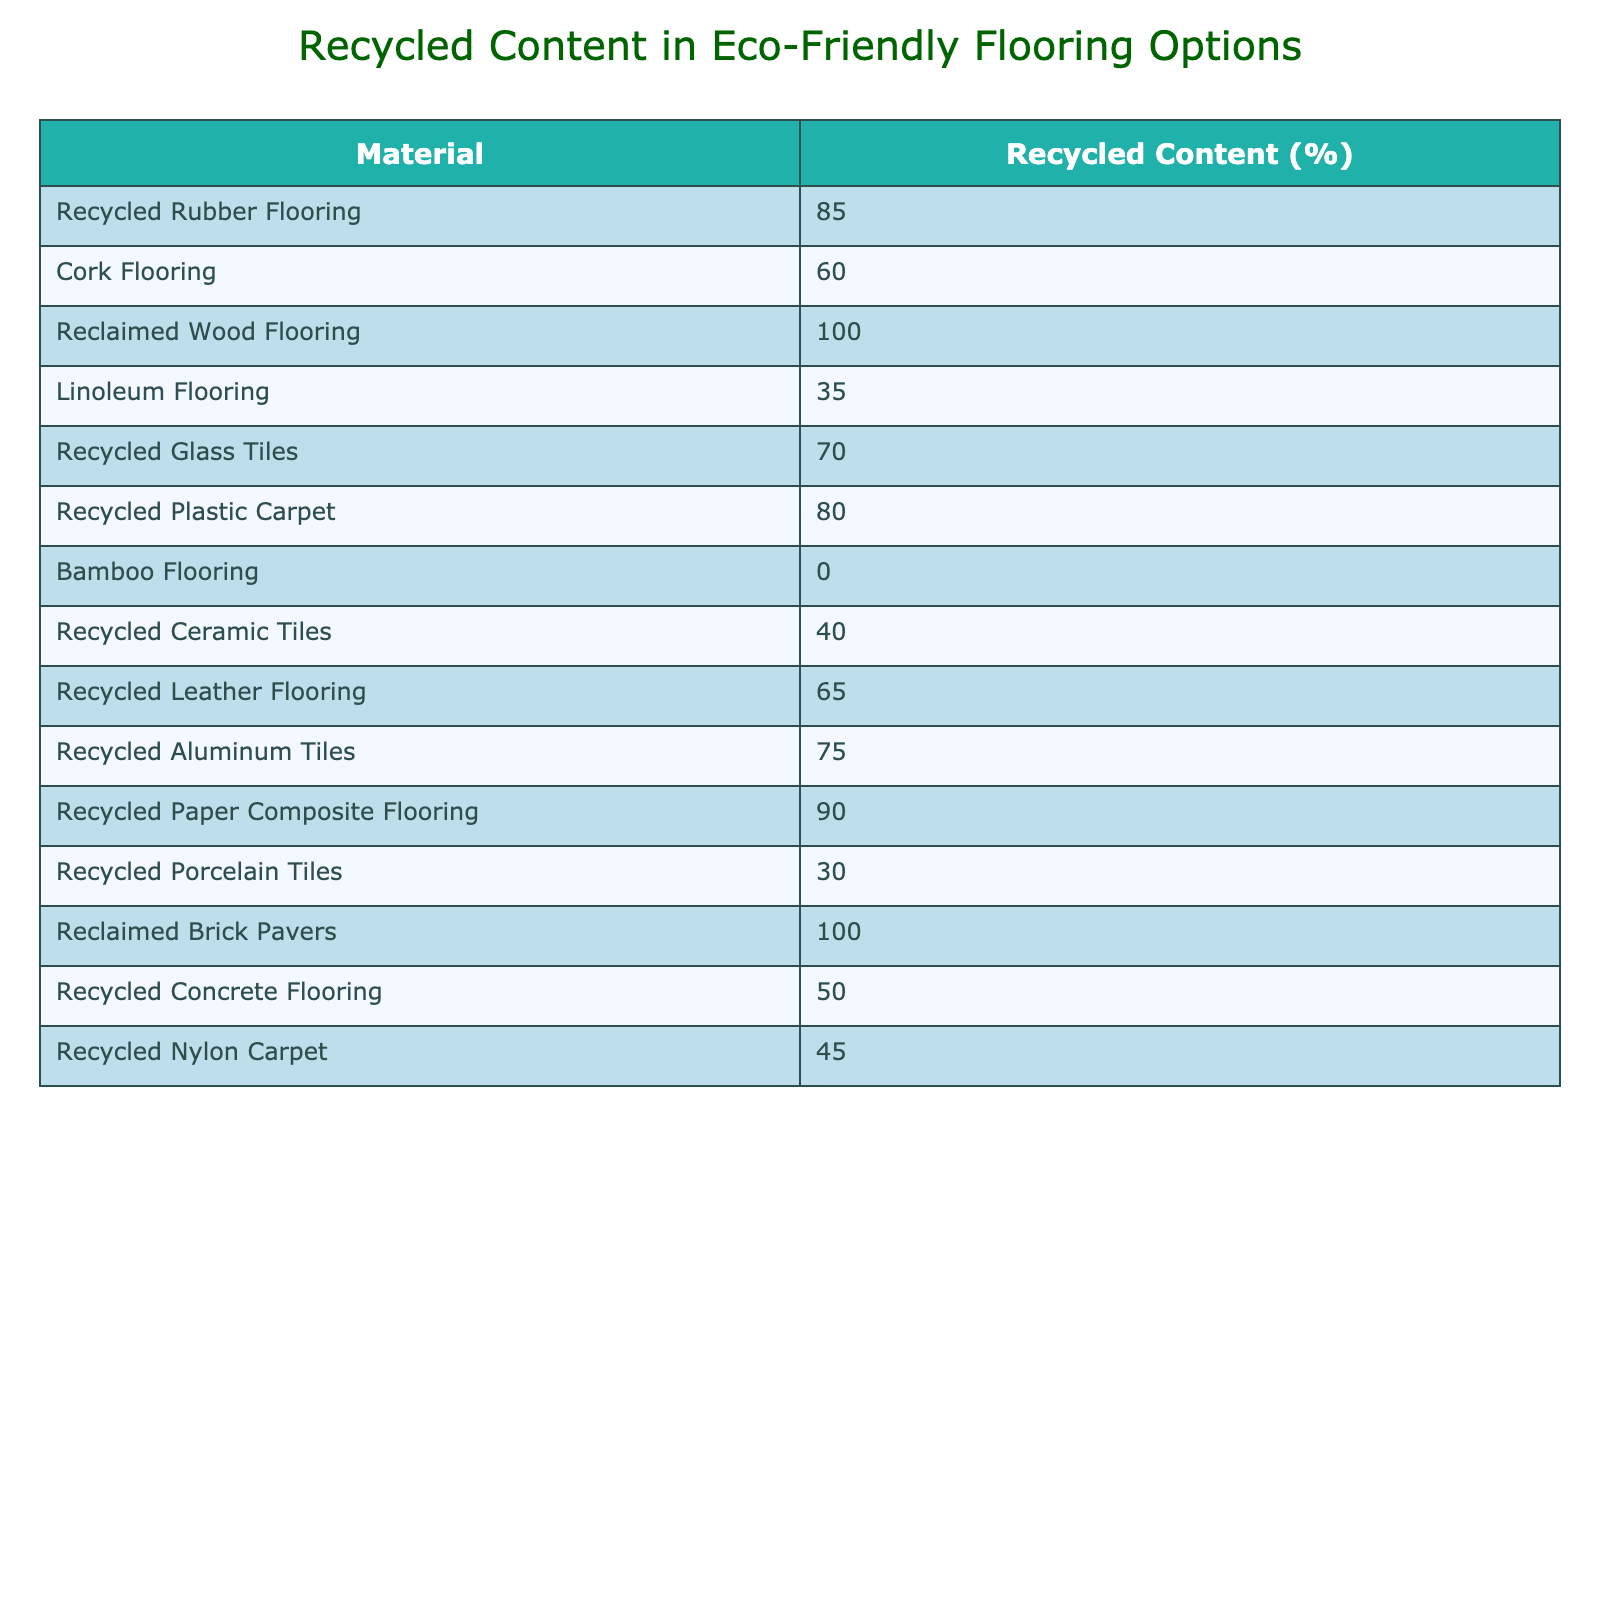What is the material with the highest recycled content percentage? By examining the table, "Reclaimed Wood Flooring" has a recycled content percentage of 100, which is higher than all other materials listed.
Answer: Reclaimed Wood Flooring What is the recycled content percentage of Recycled Plastic Carpet? The table shows that Recycled Plastic Carpet has a recycled content percentage of 80.
Answer: 80 How many materials have a recycled content percentage greater than 70? By counting the materials with percentages greater than 70, we find Recycled Rubber Flooring (85), Recycled Plastic Carpet (80), Recycled Glass Tiles (70), Recycled Paper Composite Flooring (90), and Recycled Aluminum Tiles (75). There are 5 materials in total.
Answer: 5 What is the average recycled content percentage of all the listed materials? To find the average, we sum all the recycled content percentages: (85 + 60 + 100 + 35 + 70 + 80 + 0 + 40 + 65 + 75 + 90 + 30 + 100 + 50 + 45) = 855. There are 15 materials, so the average is 855/15 = 57.
Answer: 57 Is Bamboo Flooring eco-friendly according to this table? Bamboo Flooring has a recycled content percentage of 0, indicating it does not contain any recycled materials, which suggests it is not eco-friendly based on this criterion.
Answer: No Which material has the lowest recycled content percentage? The table indicates that Bamboo Flooring has a recycled content percentage of 0, making it the material with the lowest percentage.
Answer: Bamboo Flooring What is the difference in recycled content percentage between Recycled Rubber Flooring and Recycled Concrete Flooring? The recycled content percentage of Recycled Rubber Flooring is 85, and for Recycled Concrete Flooring, it is 50. The difference is 85 - 50 = 35.
Answer: 35 List the materials that have a recycled content percentage of 40 or less. According to the table, the materials with a recycled content percentage of 40 or less are Linoleum Flooring (35), Recycled Porcelain Tiles (30), and Recycled Nylon Carpet (45). This makes a list of Linoleum Flooring and Recycled Porcelain Tiles.
Answer: Linoleum Flooring, Recycled Porcelain Tiles How many materials have a recycled content percentage between 60 and 80? The materials that fall within this range are Cork Flooring (60), Recycled Plastic Carpet (80), and Recycled Leather Flooring (65) totaling 3 materials.
Answer: 3 What percentage of the materials listed have 50% or less in recycled content? The materials with 50% or less are Linoleum Flooring (35), Recycled Porcelain Tiles (30), and Recycled Concrete Flooring (50), totaling 3 out of 15 materials. To find the percentage: (3/15)*100 = 20%.
Answer: 20% 